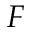<formula> <loc_0><loc_0><loc_500><loc_500>F</formula> 